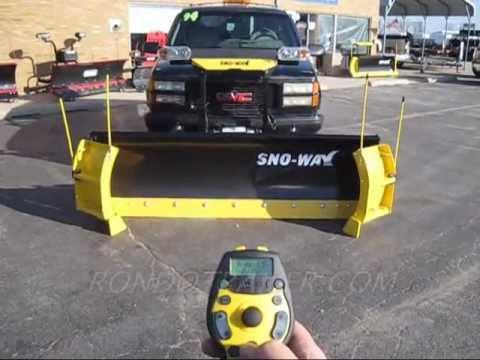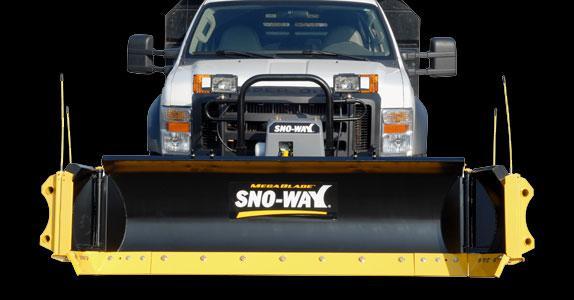The first image is the image on the left, the second image is the image on the right. Considering the images on both sides, is "The right image contains a truck attached to a snow plow that has a yellow lower border." valid? Answer yes or no. Yes. The first image is the image on the left, the second image is the image on the right. For the images displayed, is the sentence "All of the plows are black with a yellow border." factually correct? Answer yes or no. Yes. 